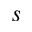<formula> <loc_0><loc_0><loc_500><loc_500>s</formula> 